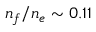<formula> <loc_0><loc_0><loc_500><loc_500>n _ { f } / n _ { e } \sim 0 . 1 1</formula> 